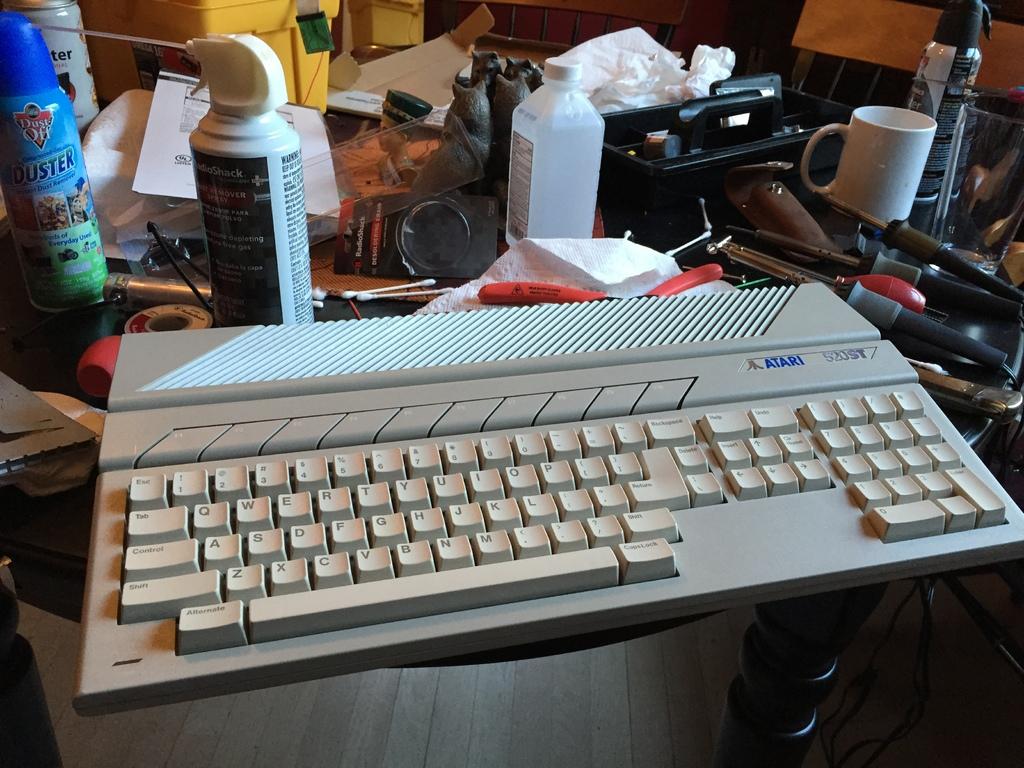What is the blue bottle used as?
Offer a terse response. Duster. What is the blue can?
Make the answer very short. Duster. 